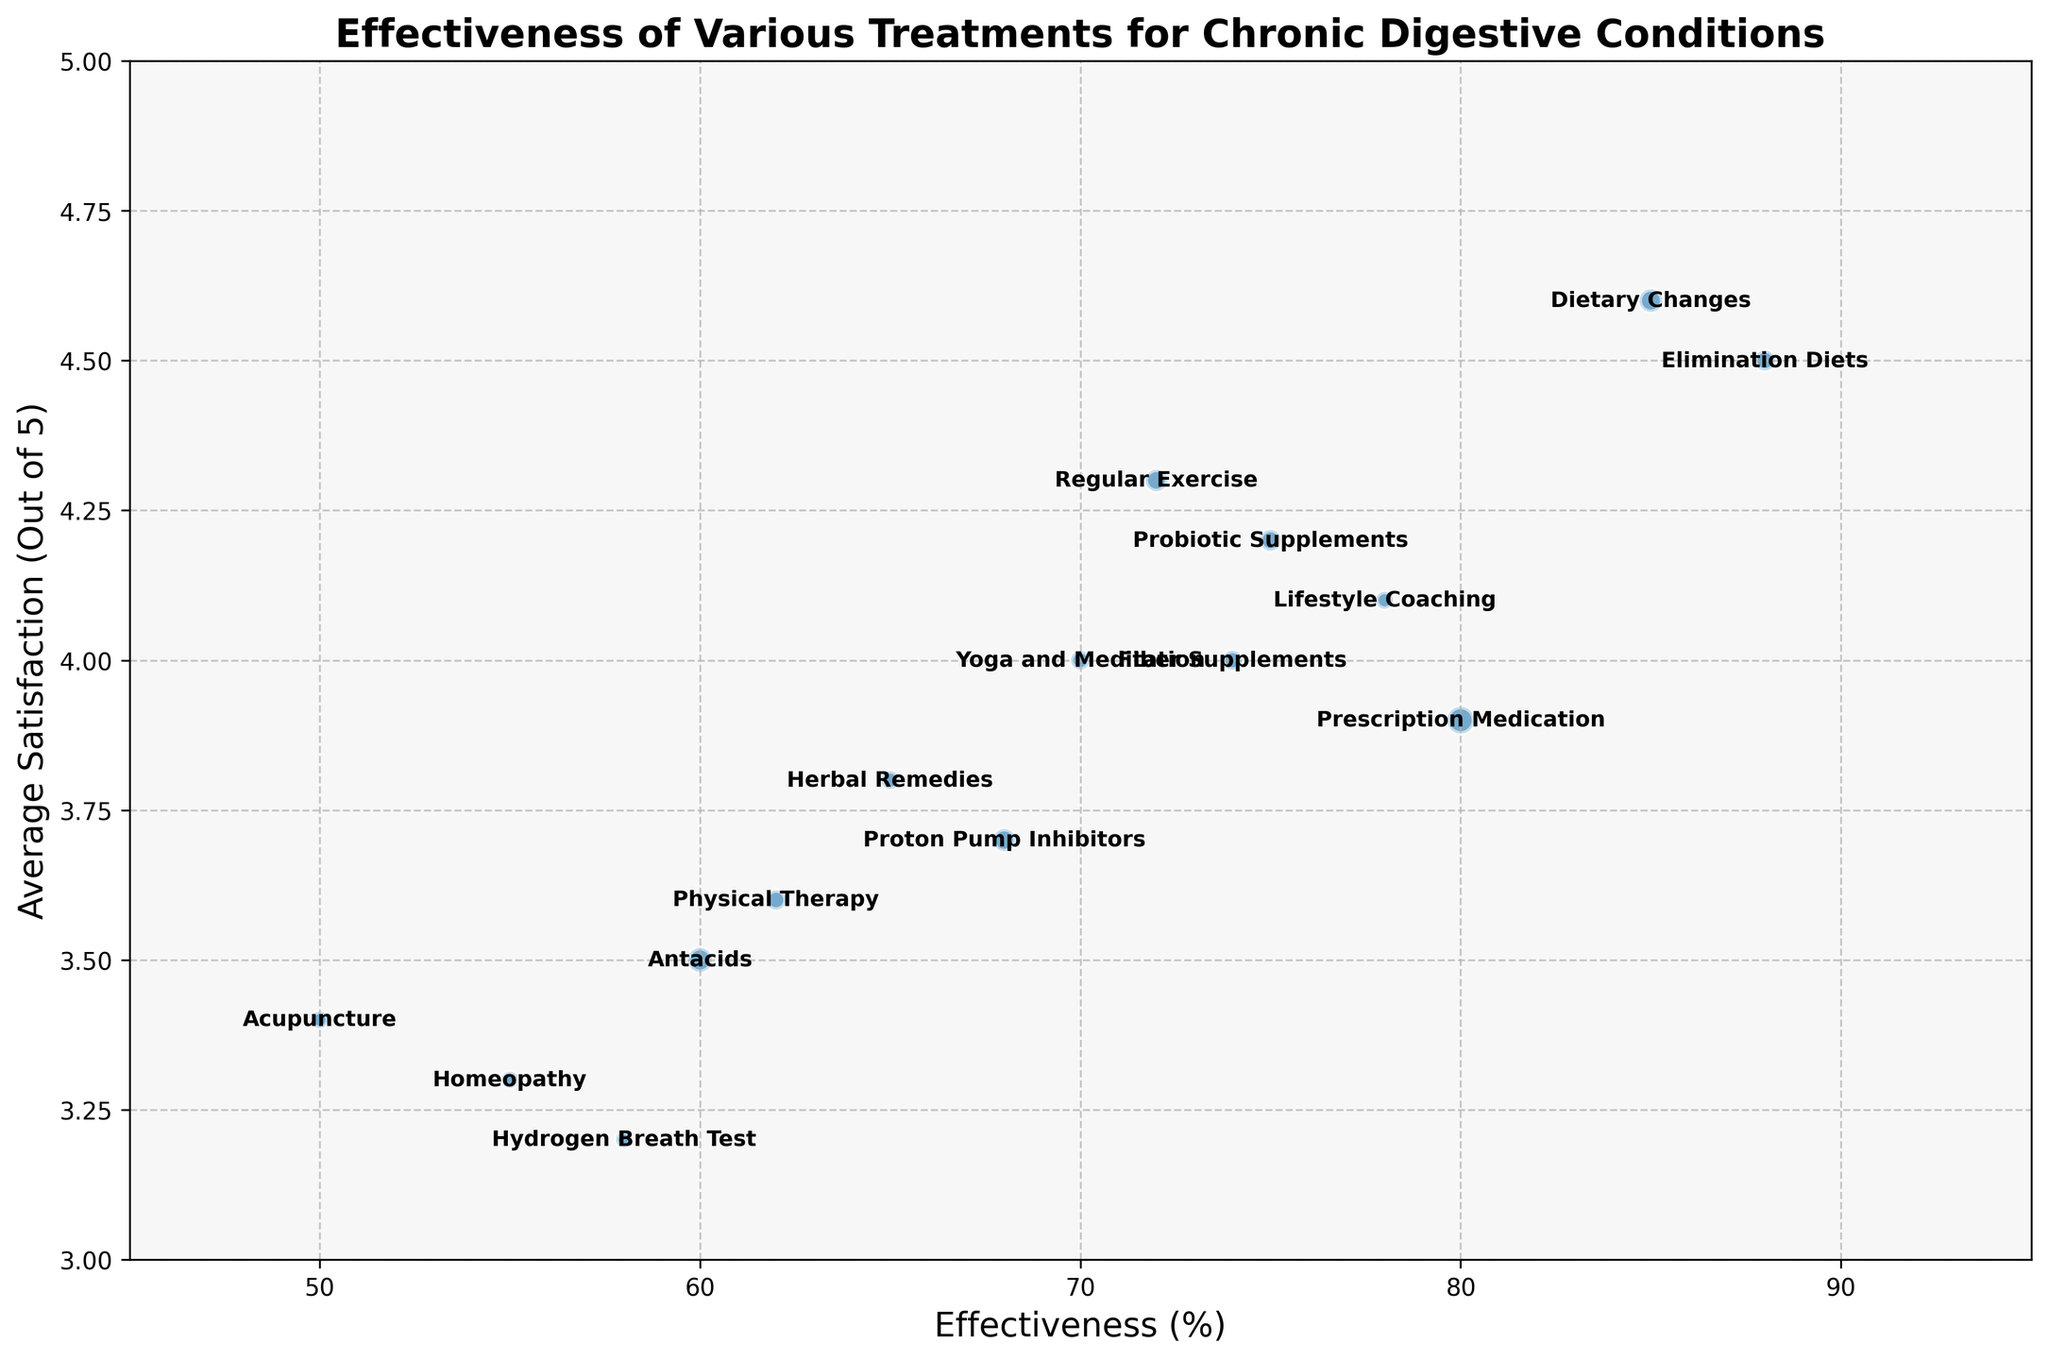What treatment shows the highest effectiveness? By inspecting the x-axis (Effectiveness) and identifying the treatment with the bubble farthest to the right, we find Dietary Changes has the highest effectiveness of 88%.
Answer: Dietary Changes Which treatment has the highest average satisfaction? By examining the y-axis (Average Satisfaction) and looking for the bubble positioned highest, Dietary Changes has the highest average satisfaction score of 4.6.
Answer: Dietary Changes How does the effectiveness of Probiotic Supplements compare to Antacids? Probiotic Supplements have an effectiveness of 75%, while Antacids have an effectiveness of 60%. This makes Probiotic Supplements 15% more effective than Antacids.
Answer: Probiotic Supplements are 15% more effective What is the combined average satisfaction of the two highest effectiveness treatments? The two highest effectiveness treatments are Elimination Diets (88%) and Dietary Changes (85%). Their average satisfactions are 4.5 and 4.6 respectively. Add these two values: 4.5 + 4.6 = 9.1. Then divide by 2 to find the combined average: 9.1 / 2 = 4.55.
Answer: 4.55 Which treatment has the largest number of patients and what is its effectiveness? The size of the bubble represents the number of patients, and the largest bubble is for Prescription Medication. Prescription Medication has 250 patients and an effectiveness of 80%.
Answer: Prescription Medication, 80% Compare the satisfaction levels of Homeopathy and Acupuncture. Homeopathy has an average satisfaction score of 3.3, while Acupuncture has an average satisfaction score of 3.4. Thus, Acupuncture has a slightly higher satisfaction level by 0.1.
Answer: Acupuncture has 0.1 higher satisfaction Which treatment has the lowest effectiveness and what is its average satisfaction rate? By identifying the treatment with the bubble farthest to the left, Acupuncture has the lowest effectiveness at 50% and an average satisfaction rate of 3.4.
Answer: Acupuncture, 3.4 What is the total number of patients for Yoga and Meditation, Herbal Remedies, and Physical Therapy combined? Yoga and Meditation has 120 patients, Herbal Remedies has 110 patients, and Physical Therapy has 130 patients. Add these numbers: 120 + 110 + 130 = 360.
Answer: 360 Compare the average satisfaction of the treatment with the smallest patient count to its effectiveness. The smallest patient count is for Hydrogen Breath Test (85 patients). Its average satisfaction is 3.2, and its effectiveness is 58%.
Answer: 3.2 satisfaction, 58% effectiveness What is the effectiveness difference between the treatments with the highest and lowest average satisfaction? The treatment with the highest average satisfaction is Dietary Changes (4.6) and the lowest is Hydrogen Breath Test (3.2). Their effectiveness are 88% and 58% respectively. The difference is: 88% - 58% = 30%.
Answer: 30% 